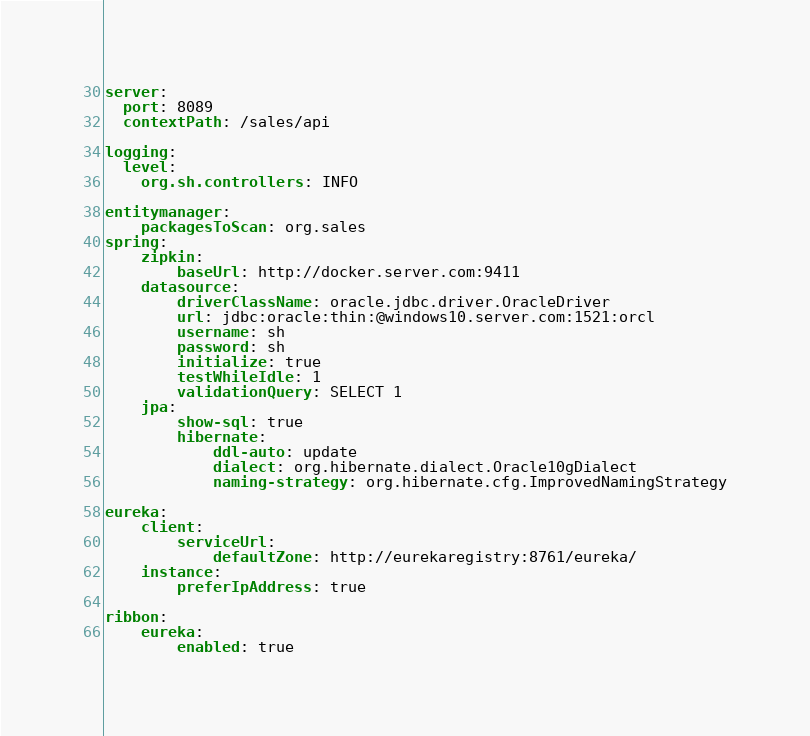<code> <loc_0><loc_0><loc_500><loc_500><_YAML_>
server:
  port: 8089
  contextPath: /sales/api

logging:
  level:
    org.sh.controllers: INFO

entitymanager:
    packagesToScan: org.sales
spring:
    zipkin:
        baseUrl: http://docker.server.com:9411
    datasource:
        driverClassName: oracle.jdbc.driver.OracleDriver
        url: jdbc:oracle:thin:@windows10.server.com:1521:orcl
        username: sh
        password: sh
        initialize: true
        testWhileIdle: 1
        validationQuery: SELECT 1
    jpa:
        show-sql: true
        hibernate:
            ddl-auto: update
            dialect: org.hibernate.dialect.Oracle10gDialect
            naming-strategy: org.hibernate.cfg.ImprovedNamingStrategy

eureka:
    client:
        serviceUrl:
            defaultZone: http://eurekaregistry:8761/eureka/
    instance:
        preferIpAddress: true

ribbon:
    eureka:
        enabled: true
</code> 